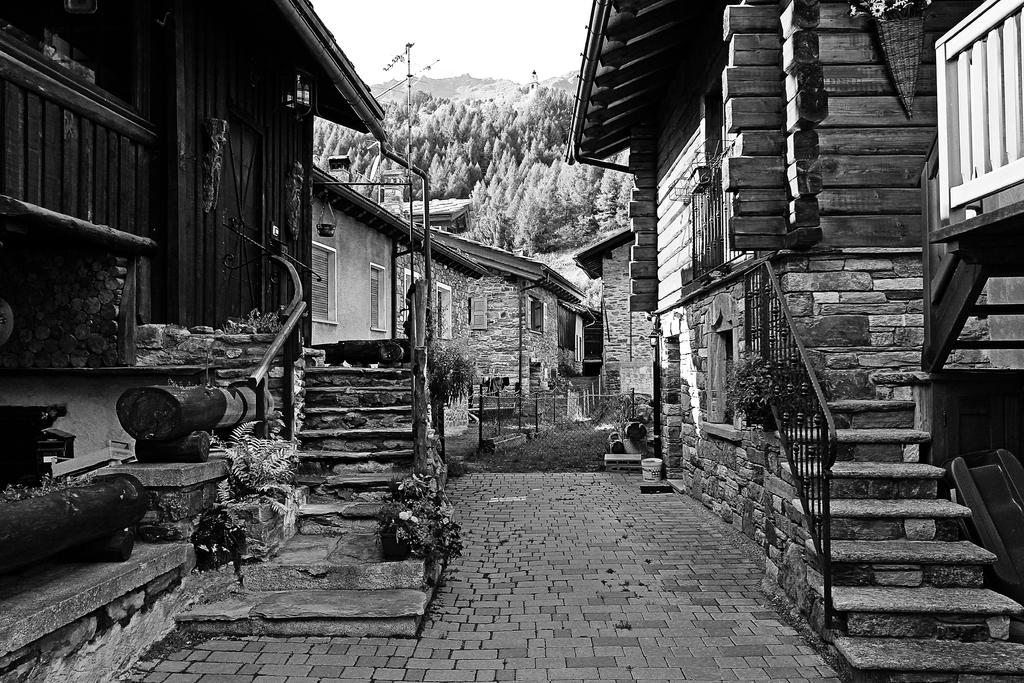What type of structures can be seen in the image? There are buildings in the image. What architectural feature is present in the image? There are windows, stairs, and net fencing in the image. What type of vegetation is visible in the image? There are trees in the image. What decorative items can be seen in the image? There are flowerpots in the image. What type of stamp can be seen on the buildings in the image? There is no stamp present on the buildings in the image; it is in black and white, and no stamps are mentioned in the facts. What type of songs can be heard playing in the background of the image? There is no audio or indication of any songs in the image; it is a still picture. 